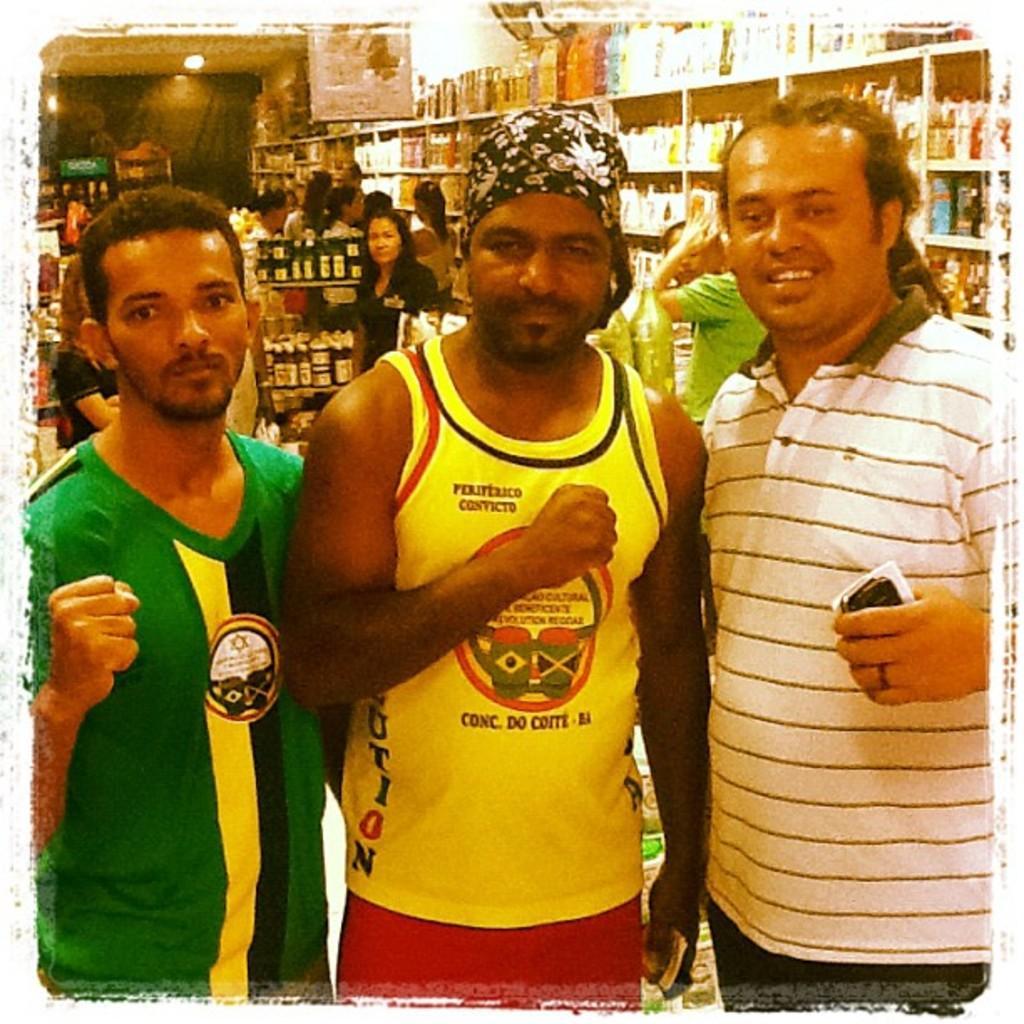How would you summarize this image in a sentence or two? In the foreground of the image there are three persons standing, closing their fist and a person wearing white color T-shirt holding some object in his hands and in the background of the image there are some persons standing near the racks and looking for some products, there are some products in the shelves. 